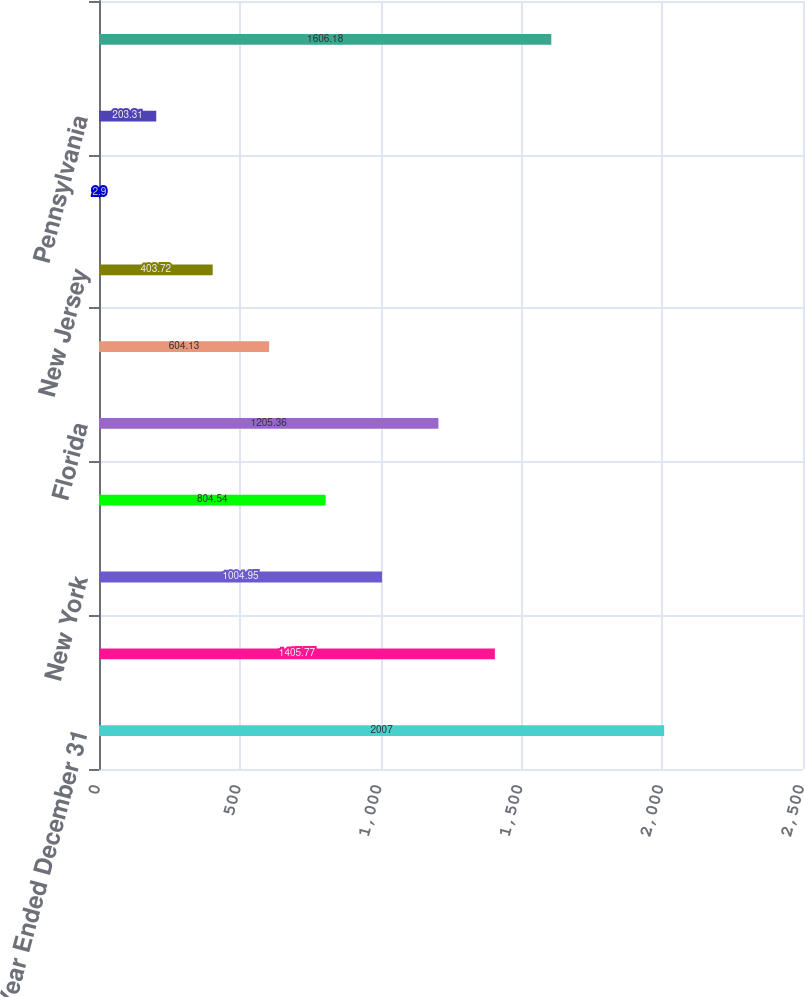Convert chart. <chart><loc_0><loc_0><loc_500><loc_500><bar_chart><fcel>Year Ended December 31<fcel>California<fcel>New York<fcel>Texas<fcel>Florida<fcel>Illinois<fcel>New Jersey<fcel>Missouri<fcel>Pennsylvania<fcel>All other states countries or<nl><fcel>2007<fcel>1405.77<fcel>1004.95<fcel>804.54<fcel>1205.36<fcel>604.13<fcel>403.72<fcel>2.9<fcel>203.31<fcel>1606.18<nl></chart> 